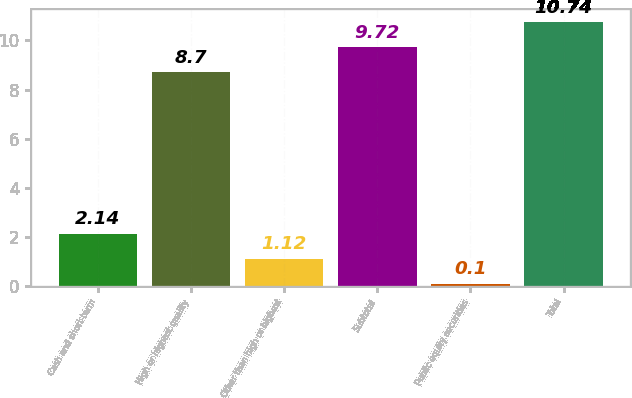Convert chart. <chart><loc_0><loc_0><loc_500><loc_500><bar_chart><fcel>Cash and short-term<fcel>High or highest quality<fcel>Other than high or highest<fcel>Subtotal<fcel>Public equity securities<fcel>Total<nl><fcel>2.14<fcel>8.7<fcel>1.12<fcel>9.72<fcel>0.1<fcel>10.74<nl></chart> 